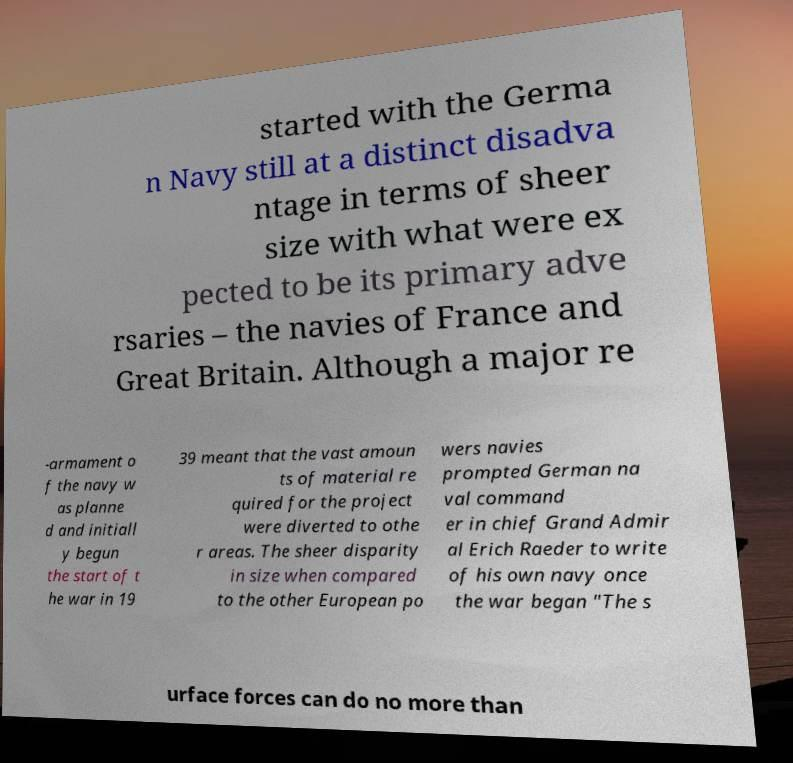I need the written content from this picture converted into text. Can you do that? started with the Germa n Navy still at a distinct disadva ntage in terms of sheer size with what were ex pected to be its primary adve rsaries – the navies of France and Great Britain. Although a major re -armament o f the navy w as planne d and initiall y begun the start of t he war in 19 39 meant that the vast amoun ts of material re quired for the project were diverted to othe r areas. The sheer disparity in size when compared to the other European po wers navies prompted German na val command er in chief Grand Admir al Erich Raeder to write of his own navy once the war began "The s urface forces can do no more than 